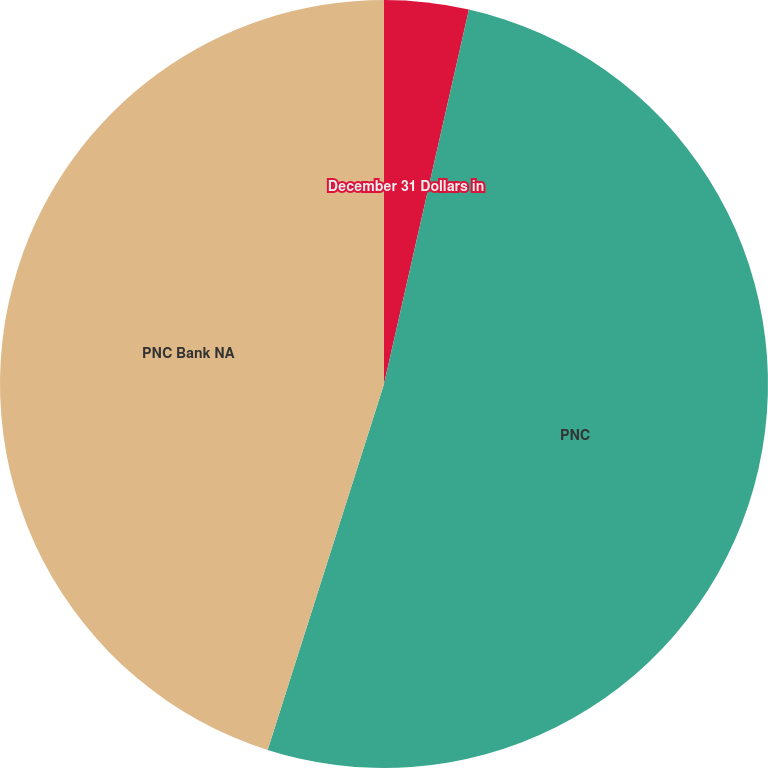<chart> <loc_0><loc_0><loc_500><loc_500><pie_chart><fcel>December 31 Dollars in<fcel>PNC<fcel>PNC Bank NA<nl><fcel>3.55%<fcel>51.35%<fcel>45.1%<nl></chart> 